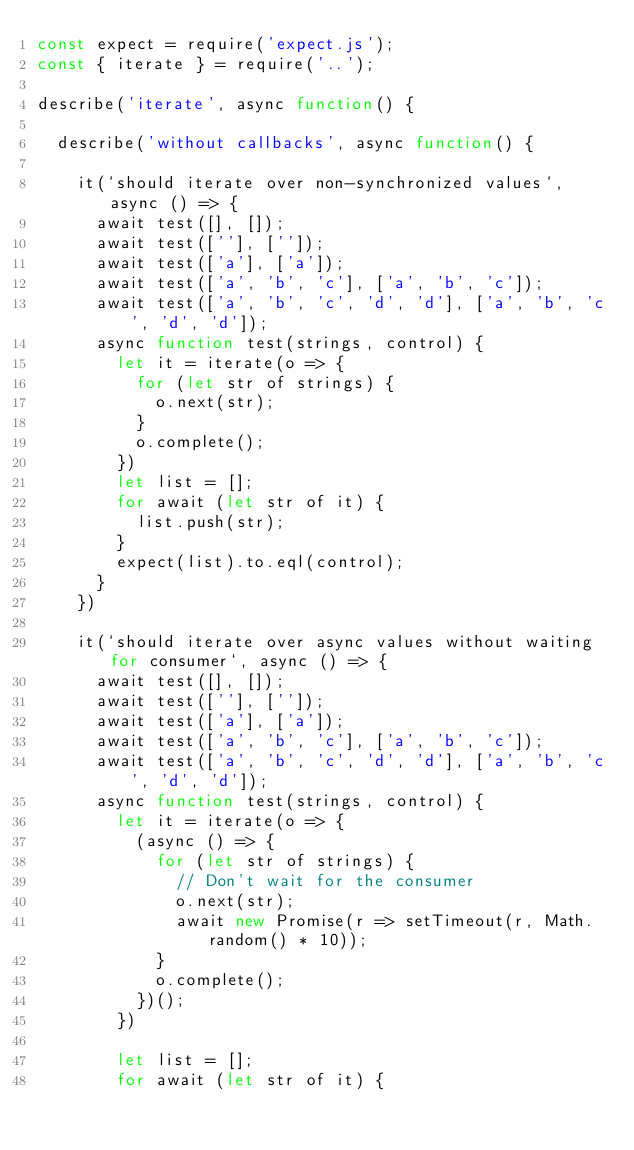Convert code to text. <code><loc_0><loc_0><loc_500><loc_500><_JavaScript_>const expect = require('expect.js');
const { iterate } = require('..');

describe('iterate', async function() {

  describe('without callbacks', async function() {

    it(`should iterate over non-synchronized values`, async () => {
      await test([], []);
      await test([''], ['']);
      await test(['a'], ['a']);
      await test(['a', 'b', 'c'], ['a', 'b', 'c']);
      await test(['a', 'b', 'c', 'd', 'd'], ['a', 'b', 'c', 'd', 'd']);
      async function test(strings, control) {
        let it = iterate(o => {
          for (let str of strings) {
            o.next(str);
          }
          o.complete();
        })
        let list = [];
        for await (let str of it) {
          list.push(str);
        }
        expect(list).to.eql(control);
      }
    })

    it(`should iterate over async values without waiting for consumer`, async () => {
      await test([], []);
      await test([''], ['']);
      await test(['a'], ['a']);
      await test(['a', 'b', 'c'], ['a', 'b', 'c']);
      await test(['a', 'b', 'c', 'd', 'd'], ['a', 'b', 'c', 'd', 'd']);
      async function test(strings, control) {
        let it = iterate(o => {
          (async () => {
            for (let str of strings) {
              // Don't wait for the consumer
              o.next(str);
              await new Promise(r => setTimeout(r, Math.random() * 10));
            }
            o.complete();
          })();
        })

        let list = [];
        for await (let str of it) {</code> 